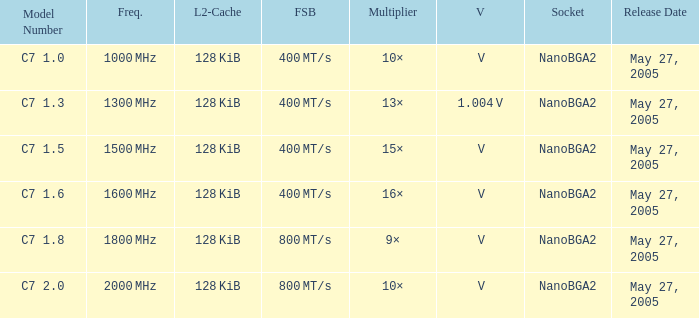What is the Release Date for Model Number c7 1.8? May 27, 2005. 